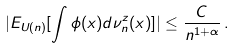<formula> <loc_0><loc_0><loc_500><loc_500>| E _ { U ( n ) } [ \int \phi ( x ) d \nu ^ { z } _ { n } ( x ) ] | \leq \frac { C } { n ^ { 1 + \alpha } } \, .</formula> 